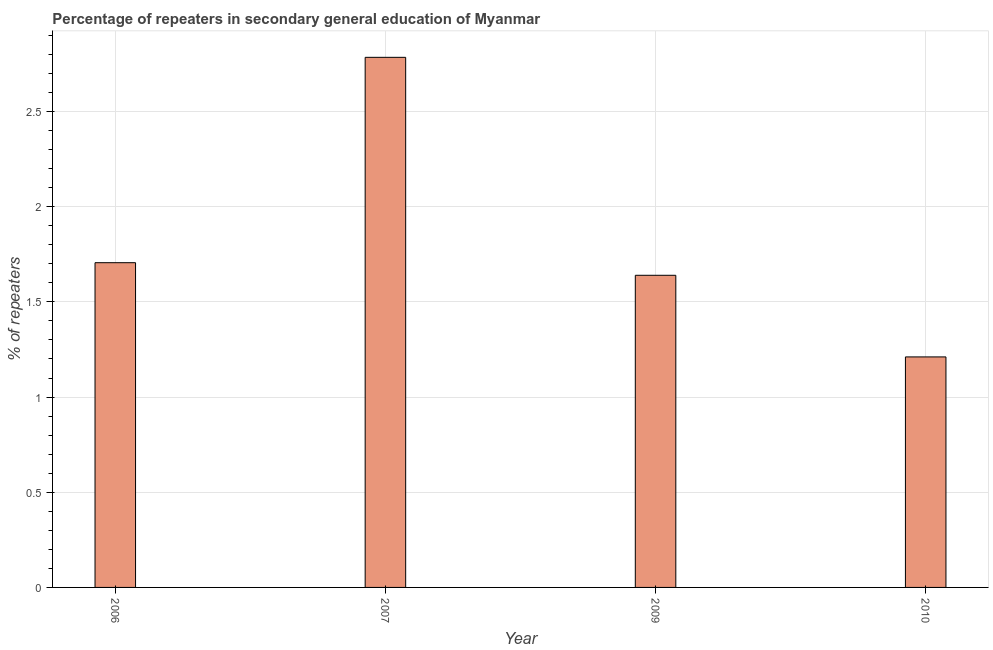Does the graph contain any zero values?
Offer a very short reply. No. Does the graph contain grids?
Make the answer very short. Yes. What is the title of the graph?
Your response must be concise. Percentage of repeaters in secondary general education of Myanmar. What is the label or title of the X-axis?
Provide a short and direct response. Year. What is the label or title of the Y-axis?
Offer a terse response. % of repeaters. What is the percentage of repeaters in 2007?
Give a very brief answer. 2.78. Across all years, what is the maximum percentage of repeaters?
Offer a terse response. 2.78. Across all years, what is the minimum percentage of repeaters?
Keep it short and to the point. 1.21. What is the sum of the percentage of repeaters?
Keep it short and to the point. 7.34. What is the difference between the percentage of repeaters in 2006 and 2007?
Make the answer very short. -1.08. What is the average percentage of repeaters per year?
Keep it short and to the point. 1.83. What is the median percentage of repeaters?
Your answer should be compact. 1.67. In how many years, is the percentage of repeaters greater than 2.5 %?
Keep it short and to the point. 1. What is the ratio of the percentage of repeaters in 2006 to that in 2009?
Make the answer very short. 1.04. What is the difference between the highest and the second highest percentage of repeaters?
Ensure brevity in your answer.  1.08. What is the difference between the highest and the lowest percentage of repeaters?
Provide a short and direct response. 1.57. How many years are there in the graph?
Ensure brevity in your answer.  4. What is the difference between two consecutive major ticks on the Y-axis?
Offer a terse response. 0.5. Are the values on the major ticks of Y-axis written in scientific E-notation?
Offer a terse response. No. What is the % of repeaters of 2006?
Ensure brevity in your answer.  1.71. What is the % of repeaters of 2007?
Keep it short and to the point. 2.78. What is the % of repeaters of 2009?
Your answer should be very brief. 1.64. What is the % of repeaters in 2010?
Offer a very short reply. 1.21. What is the difference between the % of repeaters in 2006 and 2007?
Your response must be concise. -1.08. What is the difference between the % of repeaters in 2006 and 2009?
Your answer should be very brief. 0.07. What is the difference between the % of repeaters in 2006 and 2010?
Provide a succinct answer. 0.49. What is the difference between the % of repeaters in 2007 and 2009?
Provide a short and direct response. 1.14. What is the difference between the % of repeaters in 2007 and 2010?
Keep it short and to the point. 1.57. What is the difference between the % of repeaters in 2009 and 2010?
Give a very brief answer. 0.43. What is the ratio of the % of repeaters in 2006 to that in 2007?
Offer a very short reply. 0.61. What is the ratio of the % of repeaters in 2006 to that in 2010?
Offer a very short reply. 1.41. What is the ratio of the % of repeaters in 2007 to that in 2009?
Your answer should be very brief. 1.7. What is the ratio of the % of repeaters in 2007 to that in 2010?
Offer a terse response. 2.3. What is the ratio of the % of repeaters in 2009 to that in 2010?
Your answer should be compact. 1.35. 